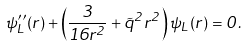<formula> <loc_0><loc_0><loc_500><loc_500>\psi _ { L } ^ { \prime \prime } ( r ) + \left ( \frac { 3 } { 1 6 r ^ { 2 } } + \tilde { q } ^ { 2 } r ^ { 2 } \right ) \psi _ { L } ( r ) = 0 .</formula> 